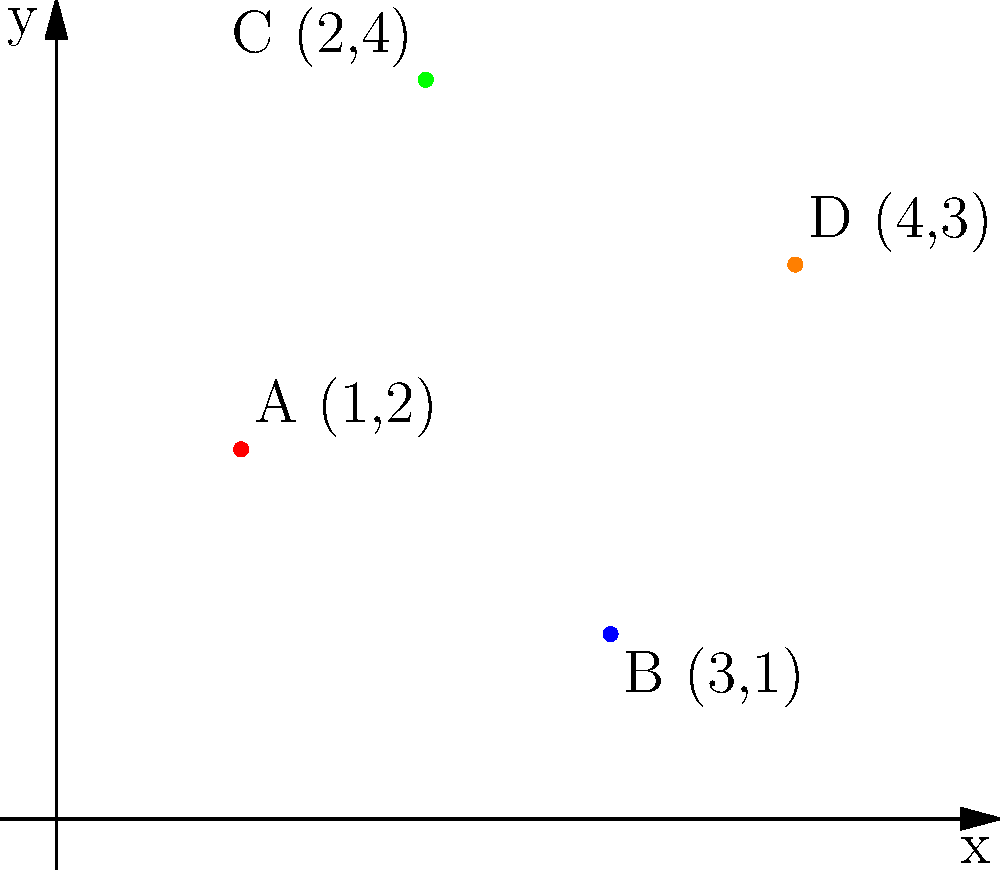A popular K-pop group's formation for their dance routine is represented on a coordinate plane. Each member's position is marked by a colored dot: A (red), B (blue), C (green), and D (orange). If the group decides to form a rectangle, which member should move, and to what position, to create the largest possible rectangle? To solve this problem, let's follow these steps:

1. Identify the current positions:
   A (1,2), B (3,1), C (2,4), D (4,3)

2. To form a rectangle, we need two pairs of parallel sides. The largest rectangle will use the points that are furthest apart.

3. The points furthest apart horizontally are A and D (x-coordinates 1 and 4).
   The points furthest apart vertically are B and C (y-coordinates 1 and 4).

4. To create the largest rectangle, we should keep these extreme points and adjust one of the other points.

5. We can either:
   a) Move B to (1,4), forming a rectangle with A, C, and D
   b) Move A to (4,2), forming a rectangle with B, C, and D

6. Both options create a 3x3 rectangle, but option (a) requires less movement.

Therefore, member B should move from (3,1) to (1,4) to create the largest possible rectangle.
Answer: B should move to (1,4) 